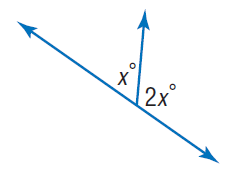Question: Find x.
Choices:
A. 30
B. 60
C. 120
D. 150
Answer with the letter. Answer: B 